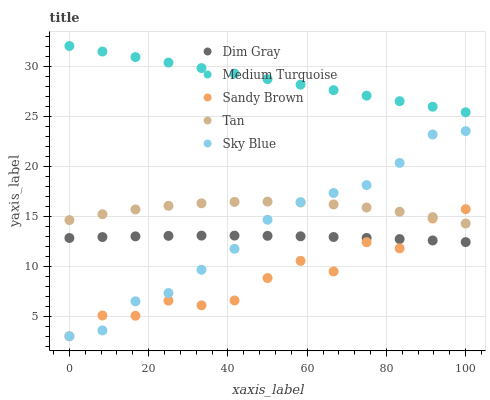Does Sandy Brown have the minimum area under the curve?
Answer yes or no. Yes. Does Medium Turquoise have the maximum area under the curve?
Answer yes or no. Yes. Does Tan have the minimum area under the curve?
Answer yes or no. No. Does Tan have the maximum area under the curve?
Answer yes or no. No. Is Medium Turquoise the smoothest?
Answer yes or no. Yes. Is Sandy Brown the roughest?
Answer yes or no. Yes. Is Tan the smoothest?
Answer yes or no. No. Is Tan the roughest?
Answer yes or no. No. Does Sky Blue have the lowest value?
Answer yes or no. Yes. Does Tan have the lowest value?
Answer yes or no. No. Does Medium Turquoise have the highest value?
Answer yes or no. Yes. Does Tan have the highest value?
Answer yes or no. No. Is Dim Gray less than Tan?
Answer yes or no. Yes. Is Tan greater than Dim Gray?
Answer yes or no. Yes. Does Sandy Brown intersect Sky Blue?
Answer yes or no. Yes. Is Sandy Brown less than Sky Blue?
Answer yes or no. No. Is Sandy Brown greater than Sky Blue?
Answer yes or no. No. Does Dim Gray intersect Tan?
Answer yes or no. No. 